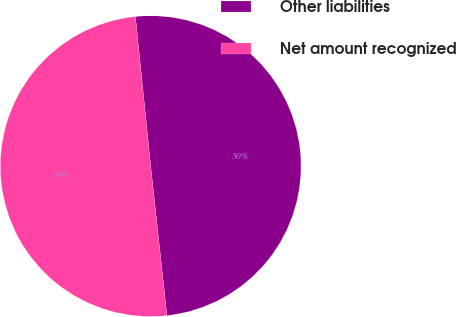Convert chart to OTSL. <chart><loc_0><loc_0><loc_500><loc_500><pie_chart><fcel>Other liabilities<fcel>Net amount recognized<nl><fcel>49.89%<fcel>50.11%<nl></chart> 